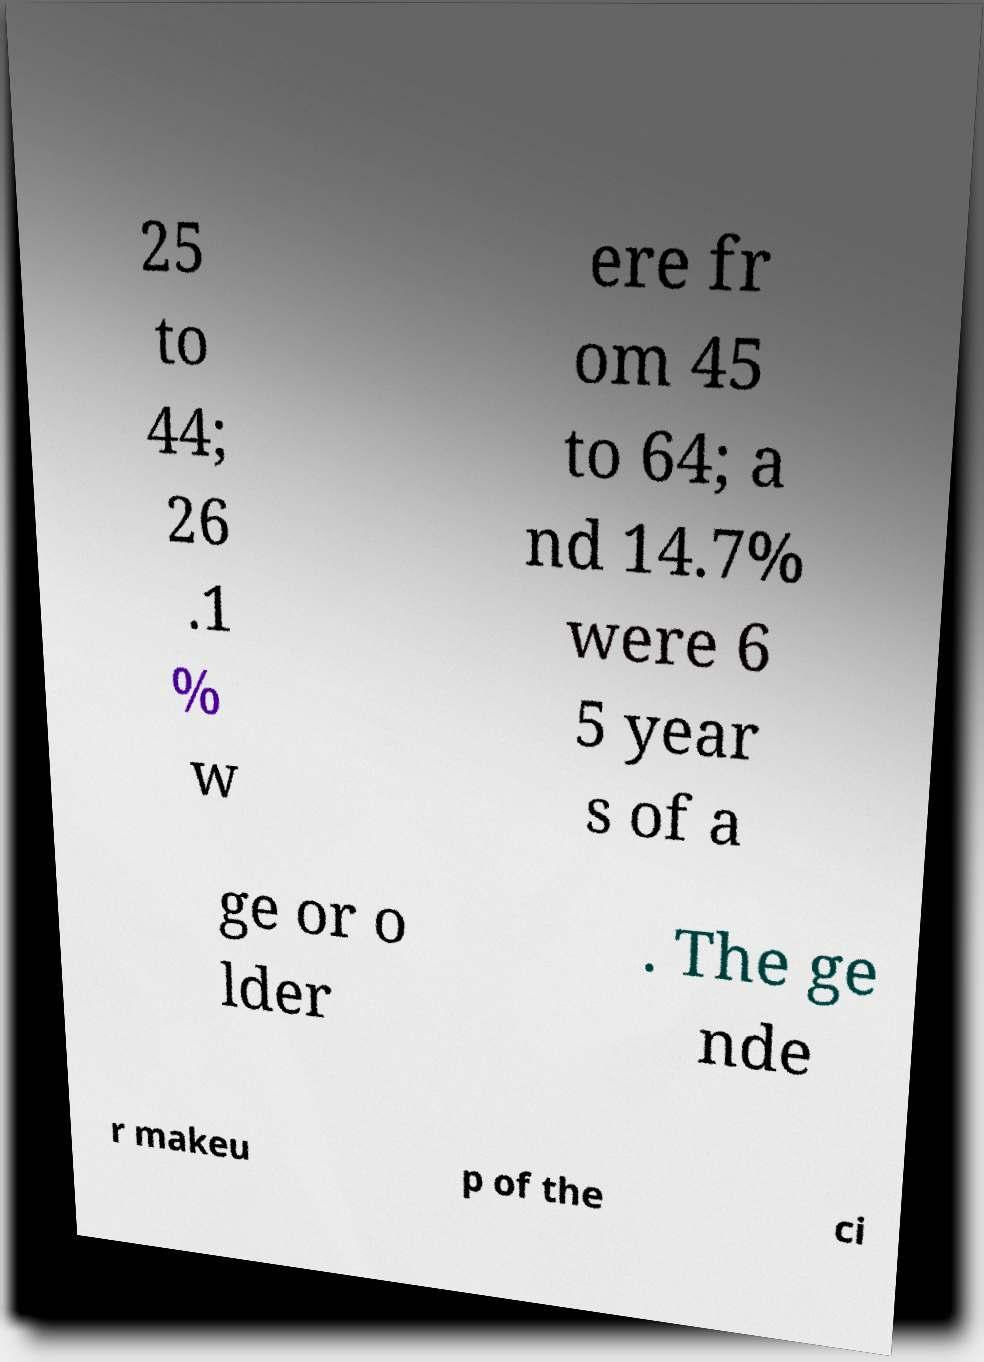Could you extract and type out the text from this image? 25 to 44; 26 .1 % w ere fr om 45 to 64; a nd 14.7% were 6 5 year s of a ge or o lder . The ge nde r makeu p of the ci 